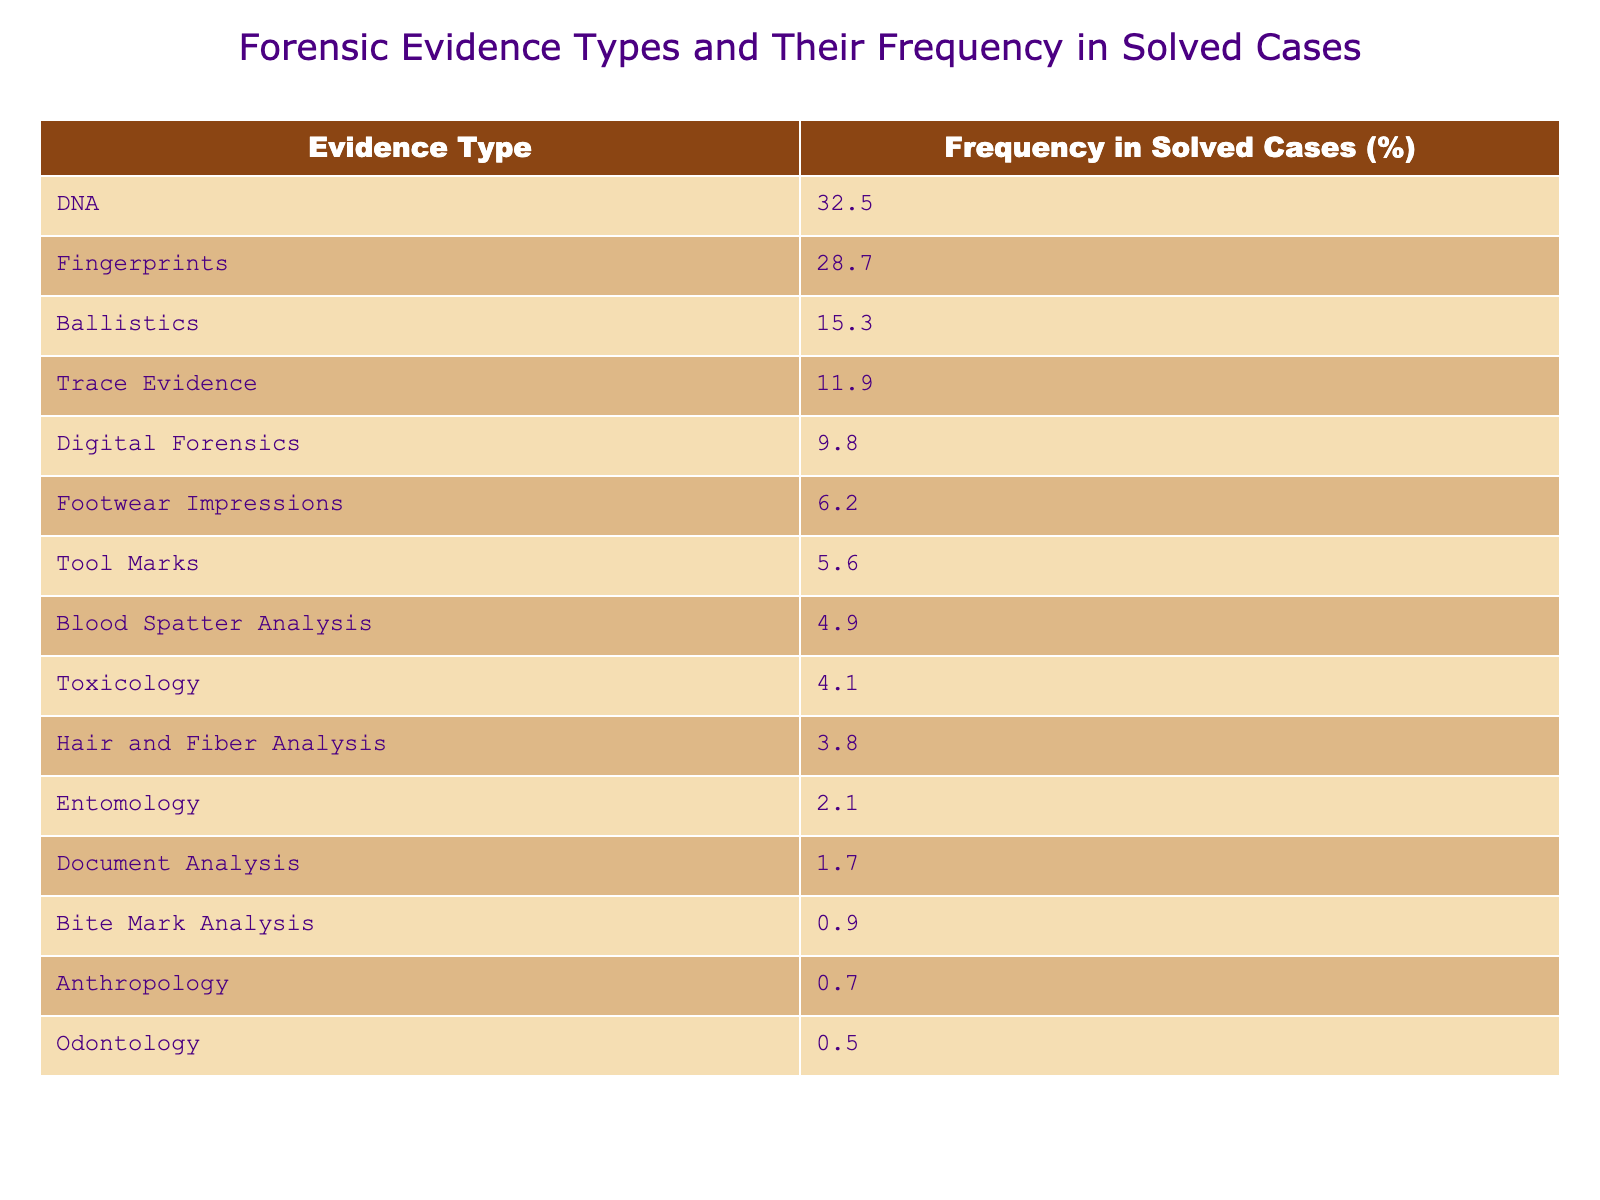What is the most common type of forensic evidence found in solved cases? The table shows the frequency of each evidence type in solved cases. The highest frequency is 32.5% for DNA evidence, making it the most common type.
Answer: DNA What percentage of solved cases involved fingerprints as forensic evidence? According to the table, fingerprints were involved in 28.7% of solved cases, as stated directly in the data.
Answer: 28.7% What is the difference in frequency between digital forensics and toxicology in solved cases? Digital forensics has a frequency of 9.8%, and toxicology has a frequency of 4.1%. The difference is 9.8% - 4.1% = 5.7%.
Answer: 5.7% How many types of forensic evidence have a frequency of less than 5% in solved cases? By reviewing the table, the types of forensic evidence with a frequency less than 5% are Blood Spatter Analysis (4.9%), Toxicology (4.1%), Hair and Fiber Analysis (3.8%), Entomology (2.1%), Document Analysis (1.7%), Bite Mark Analysis (0.9%), Anthropology (0.7%), and Odontology (0.5%). There are 8 types in total.
Answer: 8 Is the frequency of tool marks higher than that of blood spatter analysis? Tool marks have a frequency of 5.6%, and blood spatter analysis has a frequency of 4.9%. Since 5.6% > 4.9%, the statement is true.
Answer: Yes What percentage of cases involved either trace evidence or footwear impressions? The frequency for trace evidence is 11.9%, and for footwear impressions, it's 6.2%. Adding these together gives 11.9% + 6.2% = 18.1%.
Answer: 18.1% Which forensic evidence type has the lowest frequency in solved cases, and what is that frequency? Reviewing the table, the type with the lowest frequency is odontology at 0.5%.
Answer: Odontology, 0.5% What is the average frequency of blood-related evidence types (blood spatter analysis and toxicology) in solved cases? Blood spatter analysis has a frequency of 4.9% and toxicology has a frequency of 4.1%. The average is calculated as (4.9% + 4.1%) / 2 = 4.5%.
Answer: 4.5% Which two types of forensic evidence have frequencies that sum up to more than 60% in solved cases? By examining the evidence types, DNA (32.5%) and fingerprints (28.7%) add up to 61.2%. Hence, their sum exceeds 60%.
Answer: DNA and fingerprints True or False: The combined frequency of all digital forensics-related evidence types is less than 10%. Digital forensics has a frequency of 9.8%, which is indeed less than 10%. Therefore, the statement is true.
Answer: True 